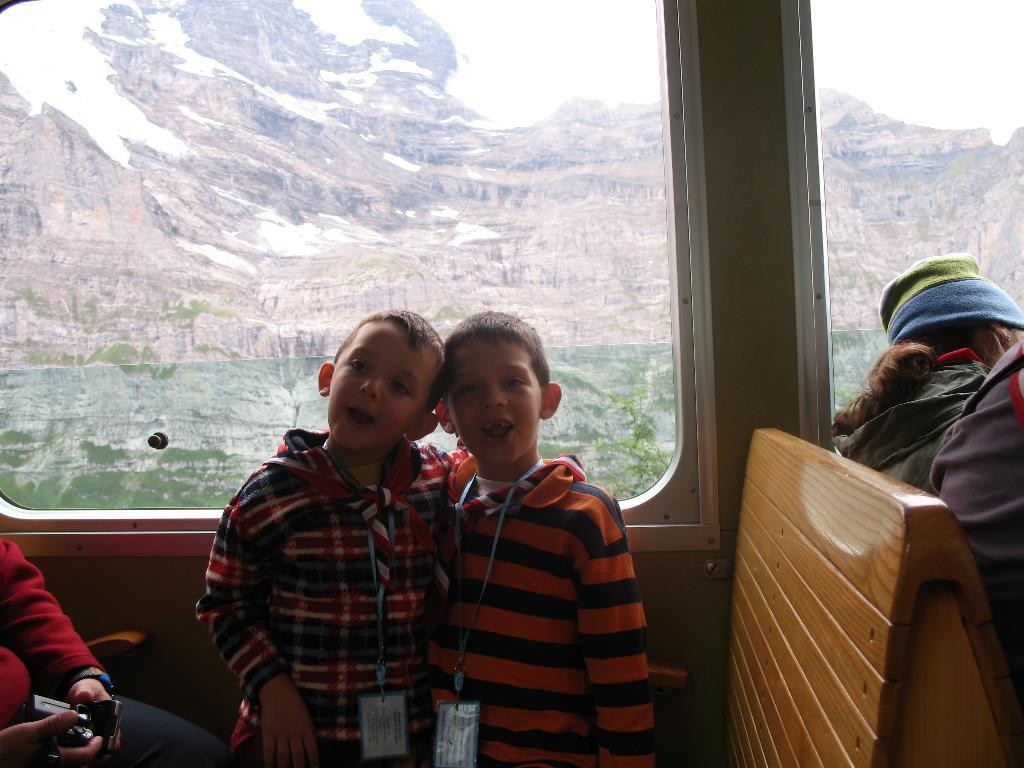What is the main subject of the image? There is a vehicle in the image. What are the people in the vehicle doing? The people are standing and sitting in the vehicle. What is located behind the vehicle? There is a glass window behind the vehicle. What can be seen through the glass window? Hills are visible through the glass window. What language is being spoken by the people in the vehicle? There is no information about the language being spoken in the image. Can you see any stems in the image? There are no stems present in the image. 